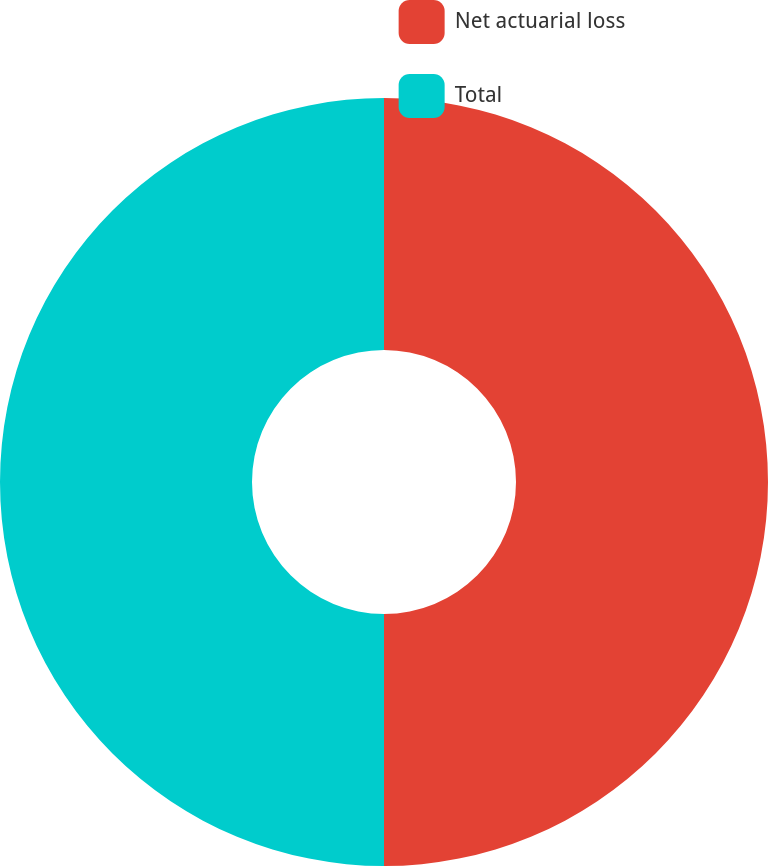<chart> <loc_0><loc_0><loc_500><loc_500><pie_chart><fcel>Net actuarial loss<fcel>Total<nl><fcel>50.0%<fcel>50.0%<nl></chart> 